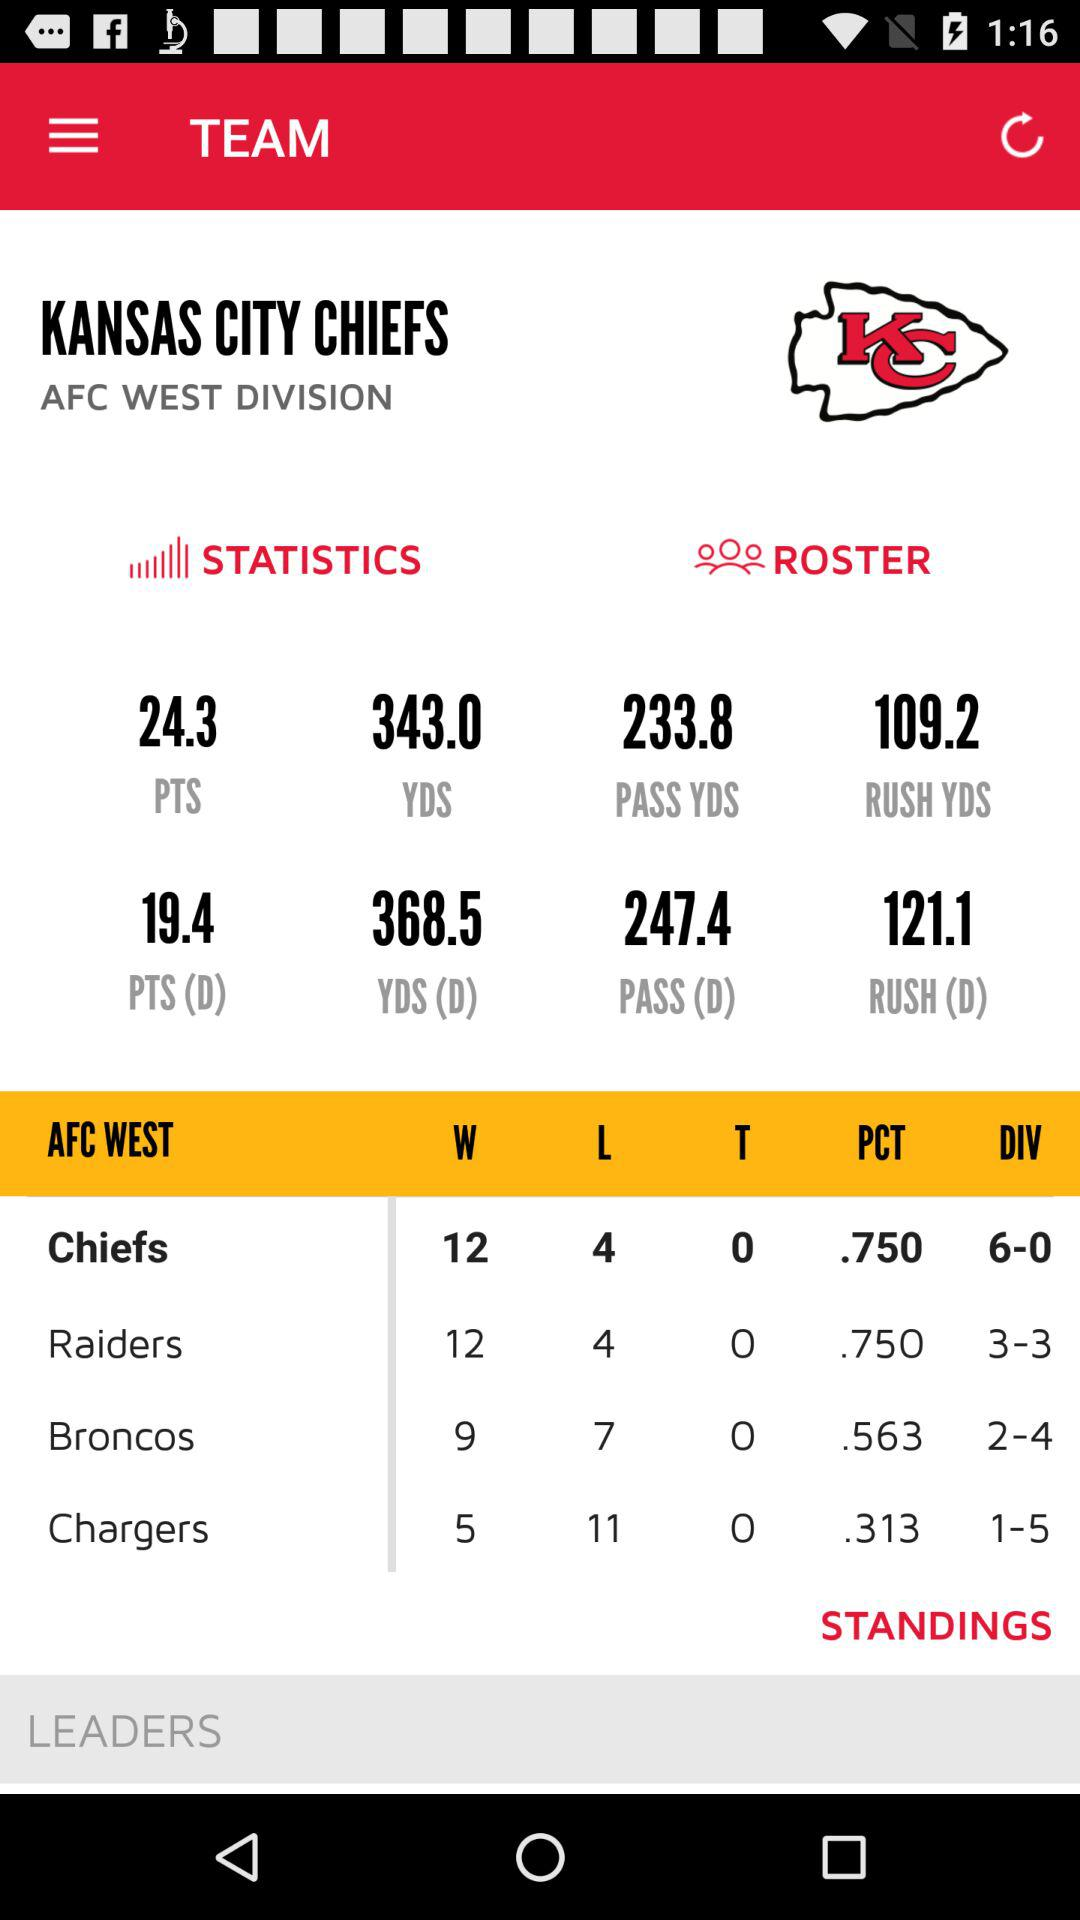How many more wins do the Chiefs have than the Chargers?
Answer the question using a single word or phrase. 7 